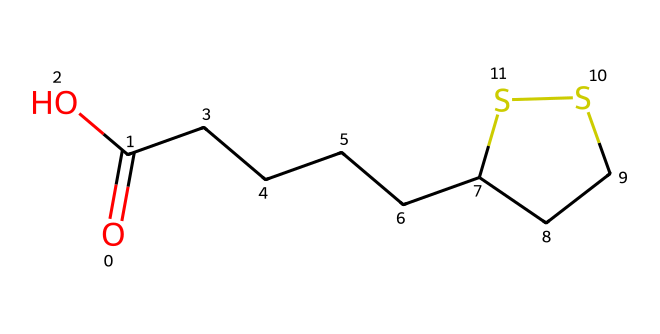What is the total number of carbon atoms in lipoic acid? By analyzing the provided SMILES representation, we can count the number of carbon (C) atoms. The structure shows 6 carbon atoms attached to the various segments, including the straight chain and the ring structure.
Answer: 6 How many sulfur atoms are present in the structure? Inspecting the given SMILES, we can locate the sulfur (S) atoms. There are 2 sulfur atoms associated with the cyclic portion of the molecule, specifically seen in the thio ring structure.
Answer: 2 What kind of functional group is present in lipoic acid? In the SMILES representation, we can identify the carboxylic acid functional group (indicated by O=C(O)). This group characterizes the acidic properties of the compound.
Answer: carboxylic acid What is the significance of the sulfur atoms in lipoic acid? The presence of sulfur atoms in lipoic acid is crucial for its biological function as an antioxidant and for energy metabolism. The sulfur contributes to the compound's capability to form disulfide bonds, which are important in enzymatic reactions.
Answer: antioxidant What is the maximum number of hydrogen atoms attached to carbon in this compound? To find the maximum number of hydrogen (H) atoms, we calculate based on the standard tetravalency of carbon, subtracting for each bond present. Considering the structure's arrangement and functional groups, the total comes out to 10 hydrogen atoms.
Answer: 10 Which ring structure is present in lipoic acid? The ring structure is a five-membered thio ring, characterized by 2 sulfur atoms and 3 carbon atoms. This unique feature distinguishes lipoic acid from other compounds.
Answer: thio ring How does the structure of lipoic acid affect its solubility? The presence of both hydrophobic (carbon chain) and hydrophilic (carboxylic acid) portions in the structure influences solubility, making lipoic acid more soluble in water compared to purely hydrophobic compounds.
Answer: amphiphilic 